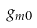<formula> <loc_0><loc_0><loc_500><loc_500>g _ { m 0 }</formula> 